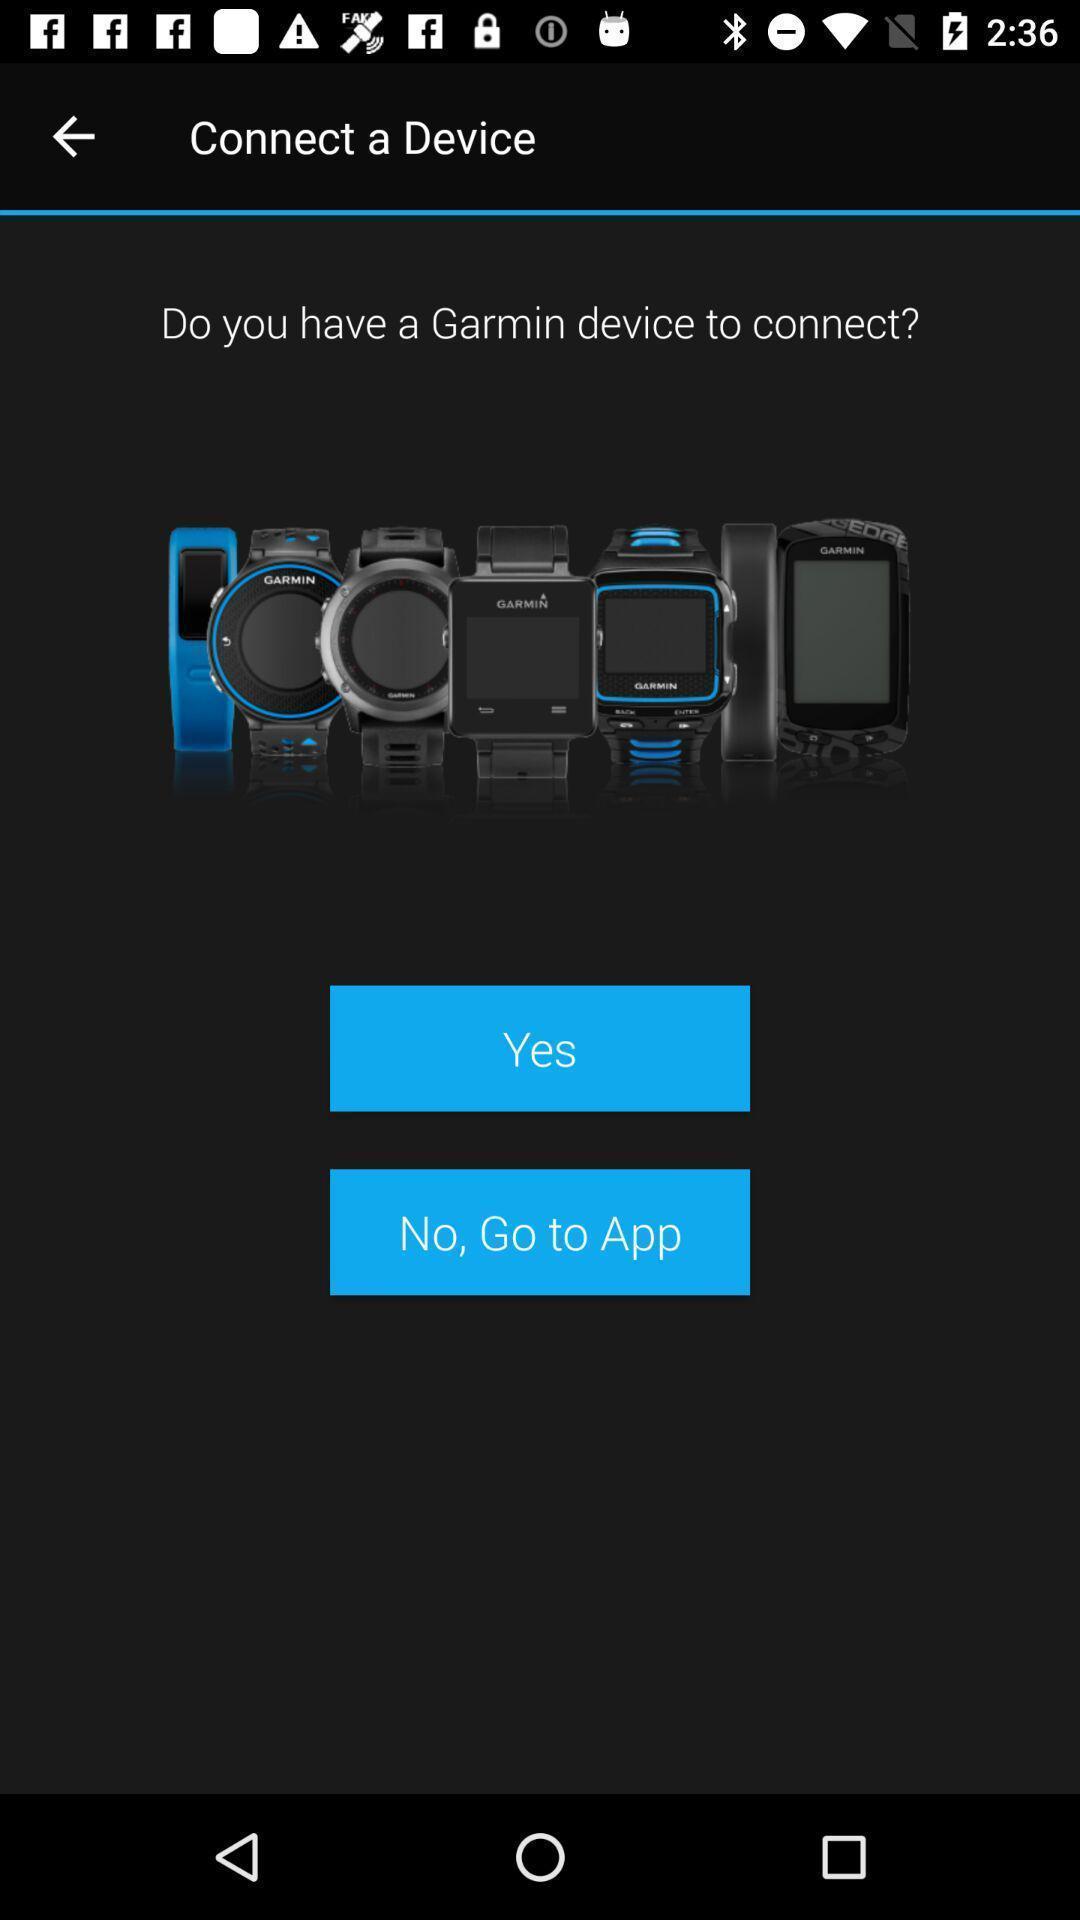Provide a detailed account of this screenshot. Page shows yes or no options to connect with device. 